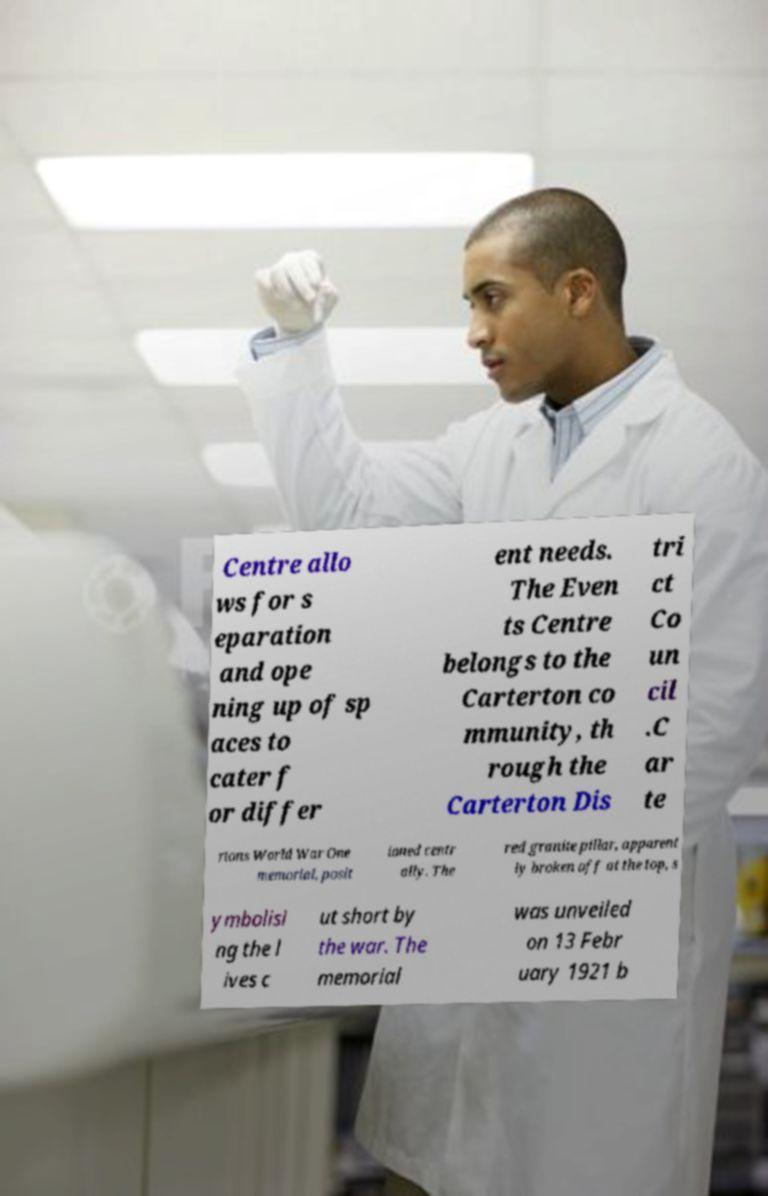Can you read and provide the text displayed in the image?This photo seems to have some interesting text. Can you extract and type it out for me? Centre allo ws for s eparation and ope ning up of sp aces to cater f or differ ent needs. The Even ts Centre belongs to the Carterton co mmunity, th rough the Carterton Dis tri ct Co un cil .C ar te rtons World War One memorial, posit ioned centr ally. The red granite pillar, apparent ly broken off at the top, s ymbolisi ng the l ives c ut short by the war. The memorial was unveiled on 13 Febr uary 1921 b 